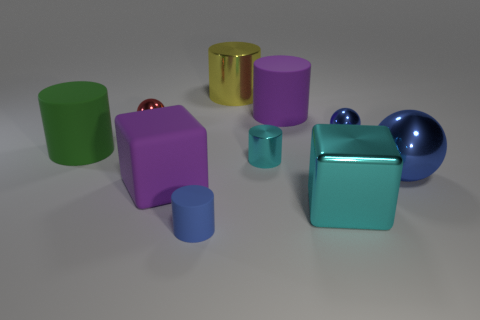How many cylinders are small metal objects or tiny blue shiny things?
Keep it short and to the point. 1. What size is the red thing?
Ensure brevity in your answer.  Small. There is a yellow cylinder; what number of large purple cylinders are in front of it?
Offer a terse response. 1. There is a shiny cylinder in front of the large matte cylinder that is in front of the purple cylinder; how big is it?
Ensure brevity in your answer.  Small. There is a large purple object behind the tiny blue metallic object; is its shape the same as the large purple matte thing in front of the small red metal sphere?
Offer a terse response. No. What shape is the large object that is on the left side of the shiny sphere left of the big cyan metal object?
Make the answer very short. Cylinder. There is a object that is both on the right side of the small cyan cylinder and in front of the purple rubber cube; how big is it?
Your answer should be compact. Large. Do the tiny cyan shiny thing and the large matte thing on the right side of the small blue rubber object have the same shape?
Keep it short and to the point. Yes. What size is the cyan metallic object that is the same shape as the large green thing?
Provide a succinct answer. Small. There is a large metal ball; is its color the same as the small thing in front of the big blue thing?
Offer a very short reply. Yes. 